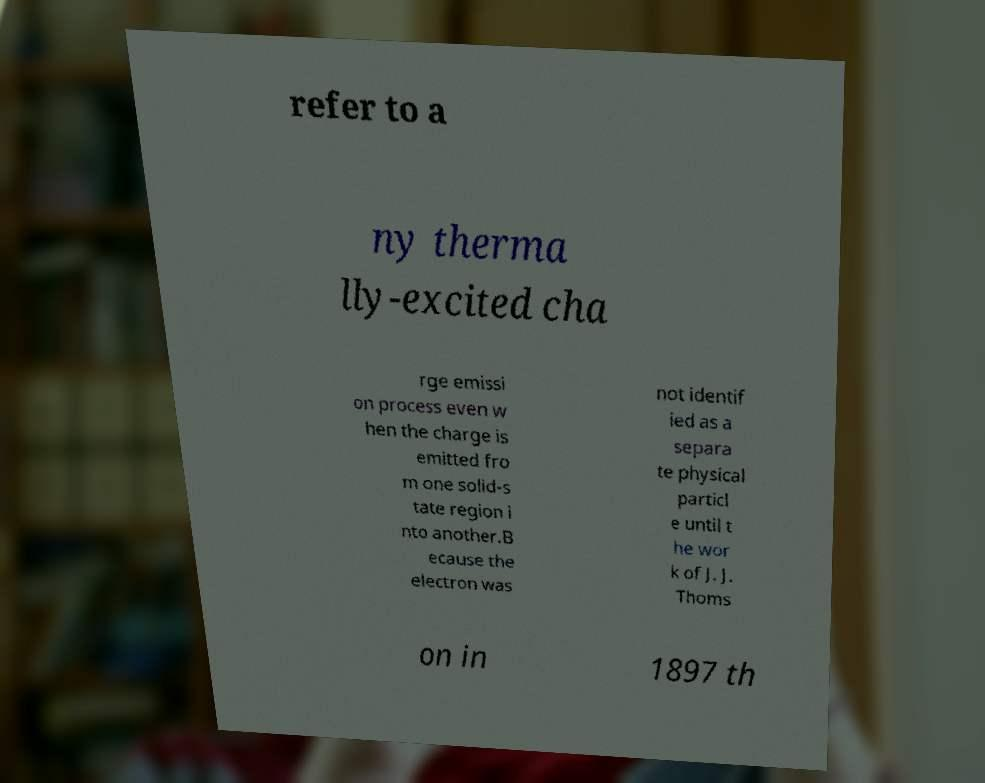Could you extract and type out the text from this image? refer to a ny therma lly-excited cha rge emissi on process even w hen the charge is emitted fro m one solid-s tate region i nto another.B ecause the electron was not identif ied as a separa te physical particl e until t he wor k of J. J. Thoms on in 1897 th 